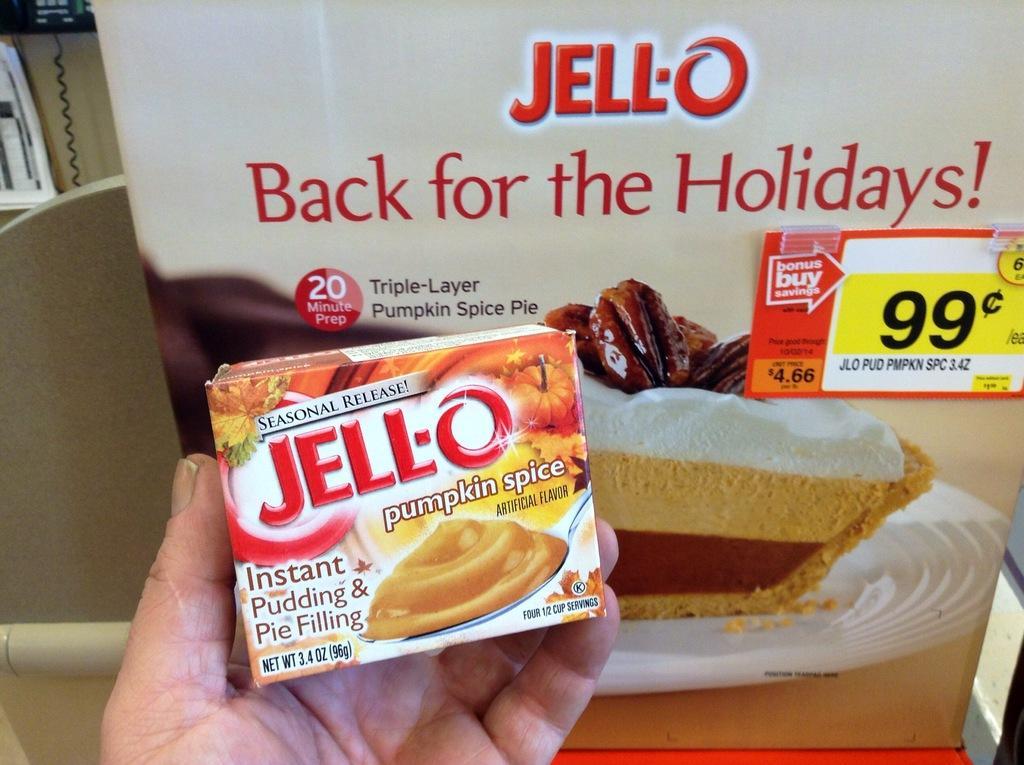Describe this image in one or two sentences. In this image, we can see hand of a person holding a box, in the background there is a poster. 